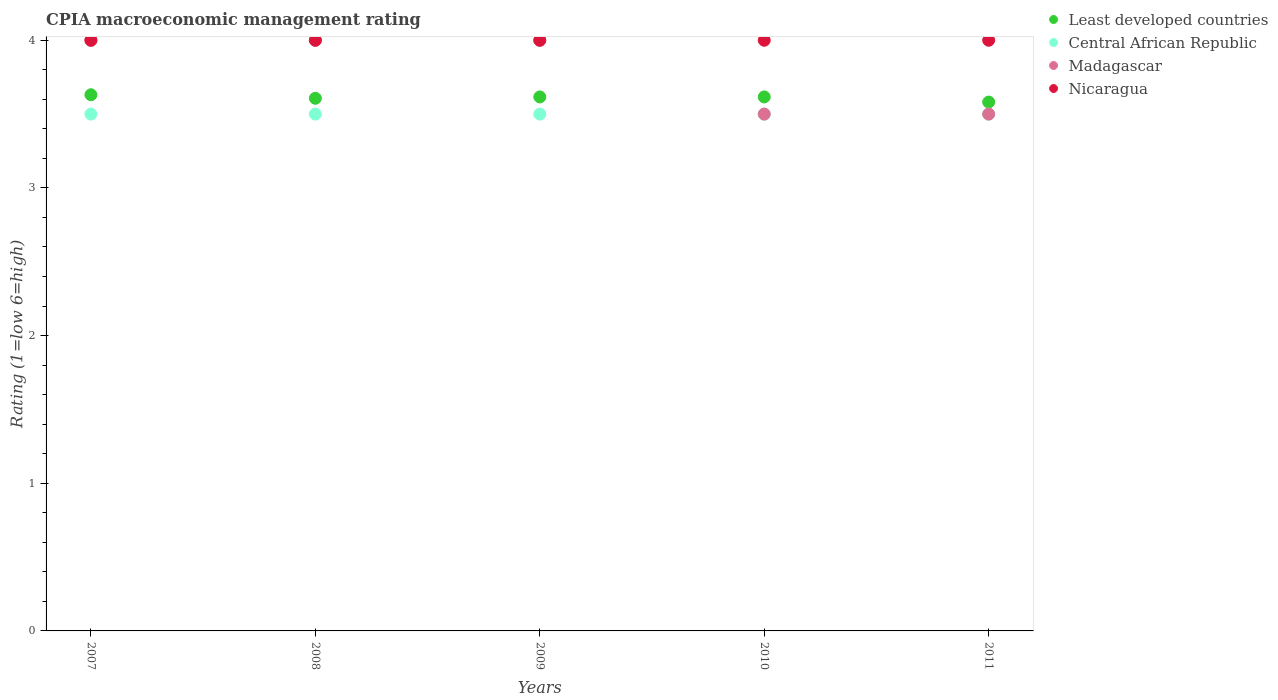Is the number of dotlines equal to the number of legend labels?
Your answer should be compact. Yes. What is the CPIA rating in Nicaragua in 2011?
Keep it short and to the point. 4. Across all years, what is the maximum CPIA rating in Least developed countries?
Provide a short and direct response. 3.63. Across all years, what is the minimum CPIA rating in Nicaragua?
Keep it short and to the point. 4. What is the total CPIA rating in Nicaragua in the graph?
Offer a very short reply. 20. What is the difference between the CPIA rating in Central African Republic in 2011 and the CPIA rating in Least developed countries in 2008?
Provide a succinct answer. -0.11. In the year 2010, what is the difference between the CPIA rating in Nicaragua and CPIA rating in Central African Republic?
Offer a very short reply. 0.5. Is the CPIA rating in Madagascar in 2008 less than that in 2009?
Provide a succinct answer. No. What is the difference between the highest and the second highest CPIA rating in Madagascar?
Provide a succinct answer. 0. Is it the case that in every year, the sum of the CPIA rating in Least developed countries and CPIA rating in Nicaragua  is greater than the sum of CPIA rating in Central African Republic and CPIA rating in Madagascar?
Your answer should be compact. Yes. Is it the case that in every year, the sum of the CPIA rating in Central African Republic and CPIA rating in Madagascar  is greater than the CPIA rating in Nicaragua?
Your answer should be very brief. Yes. Does the CPIA rating in Nicaragua monotonically increase over the years?
Provide a short and direct response. No. Is the CPIA rating in Least developed countries strictly less than the CPIA rating in Madagascar over the years?
Provide a short and direct response. No. How many dotlines are there?
Ensure brevity in your answer.  4. How many years are there in the graph?
Ensure brevity in your answer.  5. What is the difference between two consecutive major ticks on the Y-axis?
Offer a very short reply. 1. Are the values on the major ticks of Y-axis written in scientific E-notation?
Offer a very short reply. No. Does the graph contain any zero values?
Offer a very short reply. No. Does the graph contain grids?
Make the answer very short. No. Where does the legend appear in the graph?
Give a very brief answer. Top right. How are the legend labels stacked?
Ensure brevity in your answer.  Vertical. What is the title of the graph?
Offer a terse response. CPIA macroeconomic management rating. What is the Rating (1=low 6=high) in Least developed countries in 2007?
Your answer should be very brief. 3.63. What is the Rating (1=low 6=high) of Madagascar in 2007?
Provide a succinct answer. 4. What is the Rating (1=low 6=high) in Nicaragua in 2007?
Provide a succinct answer. 4. What is the Rating (1=low 6=high) of Least developed countries in 2008?
Keep it short and to the point. 3.61. What is the Rating (1=low 6=high) in Central African Republic in 2008?
Make the answer very short. 3.5. What is the Rating (1=low 6=high) in Nicaragua in 2008?
Provide a succinct answer. 4. What is the Rating (1=low 6=high) of Least developed countries in 2009?
Keep it short and to the point. 3.62. What is the Rating (1=low 6=high) in Central African Republic in 2009?
Give a very brief answer. 3.5. What is the Rating (1=low 6=high) in Nicaragua in 2009?
Keep it short and to the point. 4. What is the Rating (1=low 6=high) of Least developed countries in 2010?
Keep it short and to the point. 3.62. What is the Rating (1=low 6=high) of Central African Republic in 2010?
Your answer should be very brief. 3.5. What is the Rating (1=low 6=high) in Madagascar in 2010?
Your answer should be compact. 3.5. What is the Rating (1=low 6=high) of Nicaragua in 2010?
Your response must be concise. 4. What is the Rating (1=low 6=high) in Least developed countries in 2011?
Make the answer very short. 3.58. Across all years, what is the maximum Rating (1=low 6=high) in Least developed countries?
Give a very brief answer. 3.63. Across all years, what is the maximum Rating (1=low 6=high) in Central African Republic?
Offer a very short reply. 3.5. Across all years, what is the maximum Rating (1=low 6=high) in Madagascar?
Keep it short and to the point. 4. Across all years, what is the maximum Rating (1=low 6=high) of Nicaragua?
Offer a terse response. 4. Across all years, what is the minimum Rating (1=low 6=high) of Least developed countries?
Offer a terse response. 3.58. What is the total Rating (1=low 6=high) in Least developed countries in the graph?
Make the answer very short. 18.05. What is the total Rating (1=low 6=high) in Central African Republic in the graph?
Provide a succinct answer. 17.5. What is the total Rating (1=low 6=high) in Madagascar in the graph?
Your answer should be very brief. 19. What is the total Rating (1=low 6=high) in Nicaragua in the graph?
Provide a short and direct response. 20. What is the difference between the Rating (1=low 6=high) of Least developed countries in 2007 and that in 2008?
Make the answer very short. 0.02. What is the difference between the Rating (1=low 6=high) of Madagascar in 2007 and that in 2008?
Offer a very short reply. 0. What is the difference between the Rating (1=low 6=high) of Least developed countries in 2007 and that in 2009?
Give a very brief answer. 0.01. What is the difference between the Rating (1=low 6=high) in Least developed countries in 2007 and that in 2010?
Make the answer very short. 0.01. What is the difference between the Rating (1=low 6=high) of Central African Republic in 2007 and that in 2010?
Provide a succinct answer. 0. What is the difference between the Rating (1=low 6=high) in Madagascar in 2007 and that in 2010?
Your answer should be compact. 0.5. What is the difference between the Rating (1=low 6=high) of Least developed countries in 2007 and that in 2011?
Offer a terse response. 0.05. What is the difference between the Rating (1=low 6=high) of Madagascar in 2007 and that in 2011?
Give a very brief answer. 0.5. What is the difference between the Rating (1=low 6=high) of Least developed countries in 2008 and that in 2009?
Give a very brief answer. -0.01. What is the difference between the Rating (1=low 6=high) in Madagascar in 2008 and that in 2009?
Your answer should be very brief. 0. What is the difference between the Rating (1=low 6=high) in Nicaragua in 2008 and that in 2009?
Your response must be concise. 0. What is the difference between the Rating (1=low 6=high) in Least developed countries in 2008 and that in 2010?
Give a very brief answer. -0.01. What is the difference between the Rating (1=low 6=high) in Madagascar in 2008 and that in 2010?
Offer a terse response. 0.5. What is the difference between the Rating (1=low 6=high) in Nicaragua in 2008 and that in 2010?
Your answer should be compact. 0. What is the difference between the Rating (1=low 6=high) of Least developed countries in 2008 and that in 2011?
Give a very brief answer. 0.03. What is the difference between the Rating (1=low 6=high) in Madagascar in 2008 and that in 2011?
Your response must be concise. 0.5. What is the difference between the Rating (1=low 6=high) of Least developed countries in 2009 and that in 2010?
Your answer should be very brief. 0. What is the difference between the Rating (1=low 6=high) in Madagascar in 2009 and that in 2010?
Give a very brief answer. 0.5. What is the difference between the Rating (1=low 6=high) of Nicaragua in 2009 and that in 2010?
Keep it short and to the point. 0. What is the difference between the Rating (1=low 6=high) of Least developed countries in 2009 and that in 2011?
Keep it short and to the point. 0.03. What is the difference between the Rating (1=low 6=high) of Central African Republic in 2009 and that in 2011?
Your answer should be very brief. 0. What is the difference between the Rating (1=low 6=high) in Least developed countries in 2010 and that in 2011?
Keep it short and to the point. 0.03. What is the difference between the Rating (1=low 6=high) in Least developed countries in 2007 and the Rating (1=low 6=high) in Central African Republic in 2008?
Your answer should be compact. 0.13. What is the difference between the Rating (1=low 6=high) in Least developed countries in 2007 and the Rating (1=low 6=high) in Madagascar in 2008?
Offer a terse response. -0.37. What is the difference between the Rating (1=low 6=high) in Least developed countries in 2007 and the Rating (1=low 6=high) in Nicaragua in 2008?
Offer a very short reply. -0.37. What is the difference between the Rating (1=low 6=high) of Madagascar in 2007 and the Rating (1=low 6=high) of Nicaragua in 2008?
Your response must be concise. 0. What is the difference between the Rating (1=low 6=high) in Least developed countries in 2007 and the Rating (1=low 6=high) in Central African Republic in 2009?
Your answer should be compact. 0.13. What is the difference between the Rating (1=low 6=high) in Least developed countries in 2007 and the Rating (1=low 6=high) in Madagascar in 2009?
Keep it short and to the point. -0.37. What is the difference between the Rating (1=low 6=high) in Least developed countries in 2007 and the Rating (1=low 6=high) in Nicaragua in 2009?
Provide a succinct answer. -0.37. What is the difference between the Rating (1=low 6=high) of Central African Republic in 2007 and the Rating (1=low 6=high) of Nicaragua in 2009?
Keep it short and to the point. -0.5. What is the difference between the Rating (1=low 6=high) of Madagascar in 2007 and the Rating (1=low 6=high) of Nicaragua in 2009?
Your answer should be very brief. 0. What is the difference between the Rating (1=low 6=high) in Least developed countries in 2007 and the Rating (1=low 6=high) in Central African Republic in 2010?
Provide a short and direct response. 0.13. What is the difference between the Rating (1=low 6=high) of Least developed countries in 2007 and the Rating (1=low 6=high) of Madagascar in 2010?
Provide a succinct answer. 0.13. What is the difference between the Rating (1=low 6=high) in Least developed countries in 2007 and the Rating (1=low 6=high) in Nicaragua in 2010?
Offer a very short reply. -0.37. What is the difference between the Rating (1=low 6=high) in Central African Republic in 2007 and the Rating (1=low 6=high) in Madagascar in 2010?
Your answer should be compact. 0. What is the difference between the Rating (1=low 6=high) of Least developed countries in 2007 and the Rating (1=low 6=high) of Central African Republic in 2011?
Provide a succinct answer. 0.13. What is the difference between the Rating (1=low 6=high) of Least developed countries in 2007 and the Rating (1=low 6=high) of Madagascar in 2011?
Give a very brief answer. 0.13. What is the difference between the Rating (1=low 6=high) in Least developed countries in 2007 and the Rating (1=low 6=high) in Nicaragua in 2011?
Your answer should be compact. -0.37. What is the difference between the Rating (1=low 6=high) of Central African Republic in 2007 and the Rating (1=low 6=high) of Madagascar in 2011?
Keep it short and to the point. 0. What is the difference between the Rating (1=low 6=high) of Madagascar in 2007 and the Rating (1=low 6=high) of Nicaragua in 2011?
Ensure brevity in your answer.  0. What is the difference between the Rating (1=low 6=high) of Least developed countries in 2008 and the Rating (1=low 6=high) of Central African Republic in 2009?
Offer a very short reply. 0.11. What is the difference between the Rating (1=low 6=high) of Least developed countries in 2008 and the Rating (1=low 6=high) of Madagascar in 2009?
Your response must be concise. -0.39. What is the difference between the Rating (1=low 6=high) in Least developed countries in 2008 and the Rating (1=low 6=high) in Nicaragua in 2009?
Your answer should be very brief. -0.39. What is the difference between the Rating (1=low 6=high) of Central African Republic in 2008 and the Rating (1=low 6=high) of Madagascar in 2009?
Ensure brevity in your answer.  -0.5. What is the difference between the Rating (1=low 6=high) in Madagascar in 2008 and the Rating (1=low 6=high) in Nicaragua in 2009?
Keep it short and to the point. 0. What is the difference between the Rating (1=low 6=high) in Least developed countries in 2008 and the Rating (1=low 6=high) in Central African Republic in 2010?
Offer a very short reply. 0.11. What is the difference between the Rating (1=low 6=high) in Least developed countries in 2008 and the Rating (1=low 6=high) in Madagascar in 2010?
Provide a short and direct response. 0.11. What is the difference between the Rating (1=low 6=high) of Least developed countries in 2008 and the Rating (1=low 6=high) of Nicaragua in 2010?
Offer a very short reply. -0.39. What is the difference between the Rating (1=low 6=high) of Central African Republic in 2008 and the Rating (1=low 6=high) of Madagascar in 2010?
Offer a very short reply. 0. What is the difference between the Rating (1=low 6=high) of Least developed countries in 2008 and the Rating (1=low 6=high) of Central African Republic in 2011?
Offer a very short reply. 0.11. What is the difference between the Rating (1=low 6=high) of Least developed countries in 2008 and the Rating (1=low 6=high) of Madagascar in 2011?
Provide a succinct answer. 0.11. What is the difference between the Rating (1=low 6=high) in Least developed countries in 2008 and the Rating (1=low 6=high) in Nicaragua in 2011?
Your response must be concise. -0.39. What is the difference between the Rating (1=low 6=high) in Madagascar in 2008 and the Rating (1=low 6=high) in Nicaragua in 2011?
Provide a short and direct response. 0. What is the difference between the Rating (1=low 6=high) in Least developed countries in 2009 and the Rating (1=low 6=high) in Central African Republic in 2010?
Ensure brevity in your answer.  0.12. What is the difference between the Rating (1=low 6=high) of Least developed countries in 2009 and the Rating (1=low 6=high) of Madagascar in 2010?
Provide a short and direct response. 0.12. What is the difference between the Rating (1=low 6=high) in Least developed countries in 2009 and the Rating (1=low 6=high) in Nicaragua in 2010?
Your answer should be very brief. -0.38. What is the difference between the Rating (1=low 6=high) in Central African Republic in 2009 and the Rating (1=low 6=high) in Madagascar in 2010?
Your answer should be very brief. 0. What is the difference between the Rating (1=low 6=high) of Madagascar in 2009 and the Rating (1=low 6=high) of Nicaragua in 2010?
Provide a short and direct response. 0. What is the difference between the Rating (1=low 6=high) of Least developed countries in 2009 and the Rating (1=low 6=high) of Central African Republic in 2011?
Ensure brevity in your answer.  0.12. What is the difference between the Rating (1=low 6=high) of Least developed countries in 2009 and the Rating (1=low 6=high) of Madagascar in 2011?
Provide a succinct answer. 0.12. What is the difference between the Rating (1=low 6=high) of Least developed countries in 2009 and the Rating (1=low 6=high) of Nicaragua in 2011?
Keep it short and to the point. -0.38. What is the difference between the Rating (1=low 6=high) of Central African Republic in 2009 and the Rating (1=low 6=high) of Madagascar in 2011?
Make the answer very short. 0. What is the difference between the Rating (1=low 6=high) of Central African Republic in 2009 and the Rating (1=low 6=high) of Nicaragua in 2011?
Your answer should be very brief. -0.5. What is the difference between the Rating (1=low 6=high) in Least developed countries in 2010 and the Rating (1=low 6=high) in Central African Republic in 2011?
Keep it short and to the point. 0.12. What is the difference between the Rating (1=low 6=high) of Least developed countries in 2010 and the Rating (1=low 6=high) of Madagascar in 2011?
Offer a very short reply. 0.12. What is the difference between the Rating (1=low 6=high) in Least developed countries in 2010 and the Rating (1=low 6=high) in Nicaragua in 2011?
Offer a very short reply. -0.38. What is the average Rating (1=low 6=high) in Least developed countries per year?
Keep it short and to the point. 3.61. What is the average Rating (1=low 6=high) of Madagascar per year?
Provide a succinct answer. 3.8. What is the average Rating (1=low 6=high) in Nicaragua per year?
Ensure brevity in your answer.  4. In the year 2007, what is the difference between the Rating (1=low 6=high) of Least developed countries and Rating (1=low 6=high) of Central African Republic?
Your answer should be very brief. 0.13. In the year 2007, what is the difference between the Rating (1=low 6=high) of Least developed countries and Rating (1=low 6=high) of Madagascar?
Give a very brief answer. -0.37. In the year 2007, what is the difference between the Rating (1=low 6=high) of Least developed countries and Rating (1=low 6=high) of Nicaragua?
Your answer should be very brief. -0.37. In the year 2007, what is the difference between the Rating (1=low 6=high) of Central African Republic and Rating (1=low 6=high) of Nicaragua?
Your answer should be very brief. -0.5. In the year 2008, what is the difference between the Rating (1=low 6=high) of Least developed countries and Rating (1=low 6=high) of Central African Republic?
Provide a short and direct response. 0.11. In the year 2008, what is the difference between the Rating (1=low 6=high) of Least developed countries and Rating (1=low 6=high) of Madagascar?
Provide a short and direct response. -0.39. In the year 2008, what is the difference between the Rating (1=low 6=high) of Least developed countries and Rating (1=low 6=high) of Nicaragua?
Make the answer very short. -0.39. In the year 2008, what is the difference between the Rating (1=low 6=high) of Madagascar and Rating (1=low 6=high) of Nicaragua?
Your answer should be very brief. 0. In the year 2009, what is the difference between the Rating (1=low 6=high) in Least developed countries and Rating (1=low 6=high) in Central African Republic?
Offer a very short reply. 0.12. In the year 2009, what is the difference between the Rating (1=low 6=high) in Least developed countries and Rating (1=low 6=high) in Madagascar?
Provide a succinct answer. -0.38. In the year 2009, what is the difference between the Rating (1=low 6=high) in Least developed countries and Rating (1=low 6=high) in Nicaragua?
Ensure brevity in your answer.  -0.38. In the year 2009, what is the difference between the Rating (1=low 6=high) of Central African Republic and Rating (1=low 6=high) of Madagascar?
Make the answer very short. -0.5. In the year 2009, what is the difference between the Rating (1=low 6=high) of Central African Republic and Rating (1=low 6=high) of Nicaragua?
Ensure brevity in your answer.  -0.5. In the year 2009, what is the difference between the Rating (1=low 6=high) of Madagascar and Rating (1=low 6=high) of Nicaragua?
Give a very brief answer. 0. In the year 2010, what is the difference between the Rating (1=low 6=high) of Least developed countries and Rating (1=low 6=high) of Central African Republic?
Your response must be concise. 0.12. In the year 2010, what is the difference between the Rating (1=low 6=high) of Least developed countries and Rating (1=low 6=high) of Madagascar?
Your answer should be compact. 0.12. In the year 2010, what is the difference between the Rating (1=low 6=high) of Least developed countries and Rating (1=low 6=high) of Nicaragua?
Offer a very short reply. -0.38. In the year 2010, what is the difference between the Rating (1=low 6=high) in Central African Republic and Rating (1=low 6=high) in Madagascar?
Your answer should be very brief. 0. In the year 2011, what is the difference between the Rating (1=low 6=high) in Least developed countries and Rating (1=low 6=high) in Central African Republic?
Keep it short and to the point. 0.08. In the year 2011, what is the difference between the Rating (1=low 6=high) in Least developed countries and Rating (1=low 6=high) in Madagascar?
Offer a terse response. 0.08. In the year 2011, what is the difference between the Rating (1=low 6=high) of Least developed countries and Rating (1=low 6=high) of Nicaragua?
Your answer should be very brief. -0.42. In the year 2011, what is the difference between the Rating (1=low 6=high) of Central African Republic and Rating (1=low 6=high) of Madagascar?
Provide a succinct answer. 0. In the year 2011, what is the difference between the Rating (1=low 6=high) of Madagascar and Rating (1=low 6=high) of Nicaragua?
Your response must be concise. -0.5. What is the ratio of the Rating (1=low 6=high) in Least developed countries in 2007 to that in 2008?
Offer a terse response. 1.01. What is the ratio of the Rating (1=low 6=high) in Madagascar in 2007 to that in 2008?
Make the answer very short. 1. What is the ratio of the Rating (1=low 6=high) in Central African Republic in 2007 to that in 2009?
Ensure brevity in your answer.  1. What is the ratio of the Rating (1=low 6=high) in Madagascar in 2007 to that in 2009?
Offer a very short reply. 1. What is the ratio of the Rating (1=low 6=high) in Nicaragua in 2007 to that in 2009?
Your answer should be compact. 1. What is the ratio of the Rating (1=low 6=high) in Least developed countries in 2007 to that in 2010?
Provide a succinct answer. 1. What is the ratio of the Rating (1=low 6=high) in Madagascar in 2007 to that in 2010?
Give a very brief answer. 1.14. What is the ratio of the Rating (1=low 6=high) of Nicaragua in 2007 to that in 2010?
Ensure brevity in your answer.  1. What is the ratio of the Rating (1=low 6=high) in Least developed countries in 2007 to that in 2011?
Provide a succinct answer. 1.01. What is the ratio of the Rating (1=low 6=high) of Madagascar in 2007 to that in 2011?
Keep it short and to the point. 1.14. What is the ratio of the Rating (1=low 6=high) in Nicaragua in 2007 to that in 2011?
Your response must be concise. 1. What is the ratio of the Rating (1=low 6=high) of Least developed countries in 2008 to that in 2009?
Your answer should be very brief. 1. What is the ratio of the Rating (1=low 6=high) in Least developed countries in 2008 to that in 2010?
Your answer should be very brief. 1. What is the ratio of the Rating (1=low 6=high) in Least developed countries in 2008 to that in 2011?
Offer a terse response. 1.01. What is the ratio of the Rating (1=low 6=high) of Central African Republic in 2008 to that in 2011?
Your answer should be very brief. 1. What is the ratio of the Rating (1=low 6=high) of Madagascar in 2008 to that in 2011?
Your response must be concise. 1.14. What is the ratio of the Rating (1=low 6=high) of Nicaragua in 2008 to that in 2011?
Offer a terse response. 1. What is the ratio of the Rating (1=low 6=high) of Least developed countries in 2009 to that in 2010?
Provide a short and direct response. 1. What is the ratio of the Rating (1=low 6=high) of Nicaragua in 2009 to that in 2010?
Your response must be concise. 1. What is the ratio of the Rating (1=low 6=high) of Least developed countries in 2009 to that in 2011?
Provide a short and direct response. 1.01. What is the ratio of the Rating (1=low 6=high) in Central African Republic in 2009 to that in 2011?
Offer a terse response. 1. What is the ratio of the Rating (1=low 6=high) of Nicaragua in 2009 to that in 2011?
Give a very brief answer. 1. What is the ratio of the Rating (1=low 6=high) of Least developed countries in 2010 to that in 2011?
Your answer should be very brief. 1.01. What is the difference between the highest and the second highest Rating (1=low 6=high) in Least developed countries?
Your response must be concise. 0.01. What is the difference between the highest and the second highest Rating (1=low 6=high) in Madagascar?
Provide a succinct answer. 0. What is the difference between the highest and the second highest Rating (1=low 6=high) in Nicaragua?
Keep it short and to the point. 0. What is the difference between the highest and the lowest Rating (1=low 6=high) of Least developed countries?
Your response must be concise. 0.05. What is the difference between the highest and the lowest Rating (1=low 6=high) of Central African Republic?
Your answer should be very brief. 0. What is the difference between the highest and the lowest Rating (1=low 6=high) of Madagascar?
Give a very brief answer. 0.5. What is the difference between the highest and the lowest Rating (1=low 6=high) in Nicaragua?
Give a very brief answer. 0. 